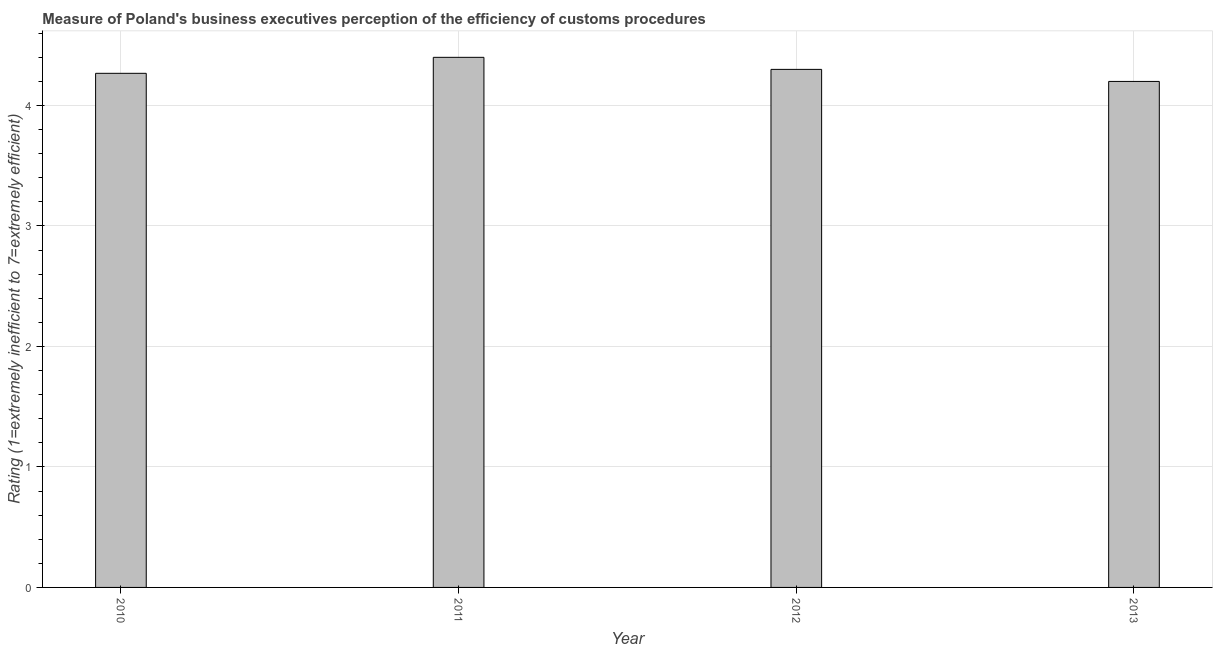Does the graph contain any zero values?
Your response must be concise. No. Does the graph contain grids?
Offer a very short reply. Yes. What is the title of the graph?
Make the answer very short. Measure of Poland's business executives perception of the efficiency of customs procedures. What is the label or title of the Y-axis?
Keep it short and to the point. Rating (1=extremely inefficient to 7=extremely efficient). What is the rating measuring burden of customs procedure in 2010?
Provide a succinct answer. 4.27. Across all years, what is the maximum rating measuring burden of customs procedure?
Offer a very short reply. 4.4. What is the sum of the rating measuring burden of customs procedure?
Your response must be concise. 17.17. What is the difference between the rating measuring burden of customs procedure in 2012 and 2013?
Make the answer very short. 0.1. What is the average rating measuring burden of customs procedure per year?
Provide a short and direct response. 4.29. What is the median rating measuring burden of customs procedure?
Provide a short and direct response. 4.28. In how many years, is the rating measuring burden of customs procedure greater than 3.4 ?
Your answer should be very brief. 4. Do a majority of the years between 2010 and 2013 (inclusive) have rating measuring burden of customs procedure greater than 1 ?
Provide a short and direct response. Yes. Is the rating measuring burden of customs procedure in 2011 less than that in 2013?
Make the answer very short. No. Is the difference between the rating measuring burden of customs procedure in 2011 and 2013 greater than the difference between any two years?
Provide a short and direct response. Yes. In how many years, is the rating measuring burden of customs procedure greater than the average rating measuring burden of customs procedure taken over all years?
Offer a very short reply. 2. How many bars are there?
Provide a short and direct response. 4. Are all the bars in the graph horizontal?
Offer a very short reply. No. How many years are there in the graph?
Ensure brevity in your answer.  4. What is the Rating (1=extremely inefficient to 7=extremely efficient) of 2010?
Offer a terse response. 4.27. What is the Rating (1=extremely inefficient to 7=extremely efficient) in 2011?
Give a very brief answer. 4.4. What is the Rating (1=extremely inefficient to 7=extremely efficient) of 2012?
Your response must be concise. 4.3. What is the difference between the Rating (1=extremely inefficient to 7=extremely efficient) in 2010 and 2011?
Make the answer very short. -0.13. What is the difference between the Rating (1=extremely inefficient to 7=extremely efficient) in 2010 and 2012?
Keep it short and to the point. -0.03. What is the difference between the Rating (1=extremely inefficient to 7=extremely efficient) in 2010 and 2013?
Keep it short and to the point. 0.07. What is the difference between the Rating (1=extremely inefficient to 7=extremely efficient) in 2012 and 2013?
Provide a short and direct response. 0.1. What is the ratio of the Rating (1=extremely inefficient to 7=extremely efficient) in 2010 to that in 2012?
Offer a very short reply. 0.99. What is the ratio of the Rating (1=extremely inefficient to 7=extremely efficient) in 2010 to that in 2013?
Your response must be concise. 1.02. What is the ratio of the Rating (1=extremely inefficient to 7=extremely efficient) in 2011 to that in 2012?
Your answer should be compact. 1.02. What is the ratio of the Rating (1=extremely inefficient to 7=extremely efficient) in 2011 to that in 2013?
Provide a succinct answer. 1.05. 